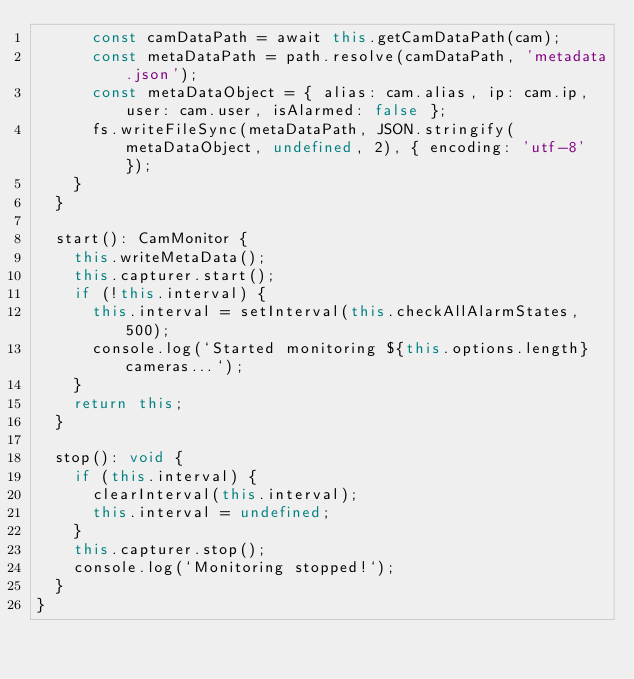<code> <loc_0><loc_0><loc_500><loc_500><_TypeScript_>      const camDataPath = await this.getCamDataPath(cam);
      const metaDataPath = path.resolve(camDataPath, 'metadata.json');
      const metaDataObject = { alias: cam.alias, ip: cam.ip, user: cam.user, isAlarmed: false };
      fs.writeFileSync(metaDataPath, JSON.stringify(metaDataObject, undefined, 2), { encoding: 'utf-8' });
    }
  }

  start(): CamMonitor {
    this.writeMetaData();
    this.capturer.start();
    if (!this.interval) {
      this.interval = setInterval(this.checkAllAlarmStates, 500);
      console.log(`Started monitoring ${this.options.length} cameras...`);
    }
    return this;
  }

  stop(): void {
    if (this.interval) {
      clearInterval(this.interval);
      this.interval = undefined;
    }
    this.capturer.stop();
    console.log(`Monitoring stopped!`);
  }
}
</code> 